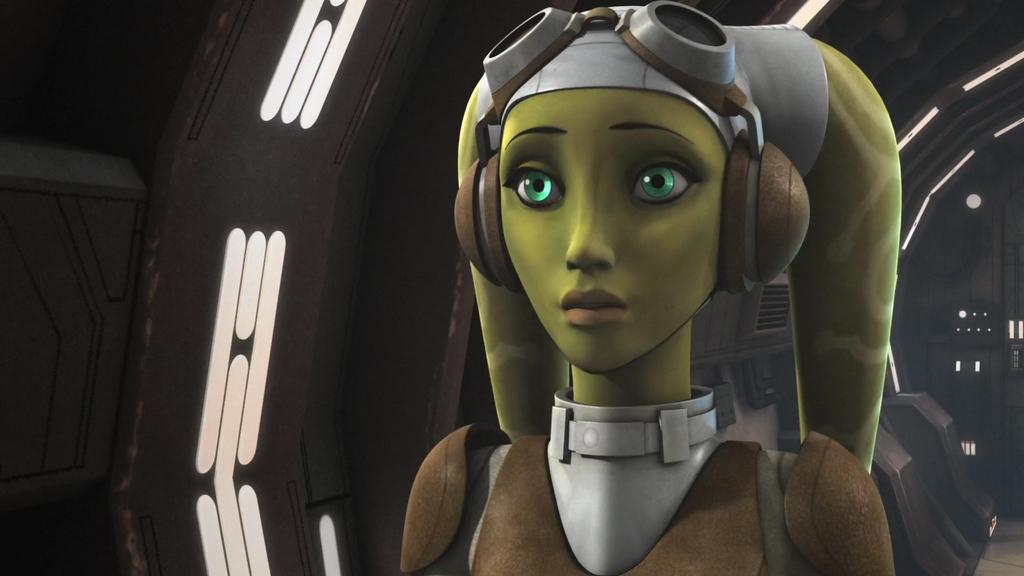What type of image is being described? The image is animated. Can you describe the person in the image? There is a person sitting in the image. What design is featured on the clock in the image? There is no clock present in the image; it only mentions a person sitting in an animated image. 